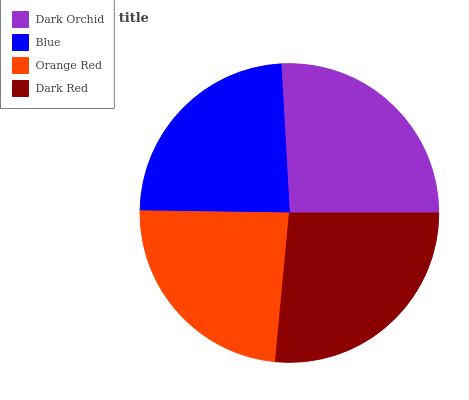Is Orange Red the minimum?
Answer yes or no. Yes. Is Dark Red the maximum?
Answer yes or no. Yes. Is Blue the minimum?
Answer yes or no. No. Is Blue the maximum?
Answer yes or no. No. Is Dark Orchid greater than Blue?
Answer yes or no. Yes. Is Blue less than Dark Orchid?
Answer yes or no. Yes. Is Blue greater than Dark Orchid?
Answer yes or no. No. Is Dark Orchid less than Blue?
Answer yes or no. No. Is Dark Orchid the high median?
Answer yes or no. Yes. Is Blue the low median?
Answer yes or no. Yes. Is Dark Red the high median?
Answer yes or no. No. Is Orange Red the low median?
Answer yes or no. No. 